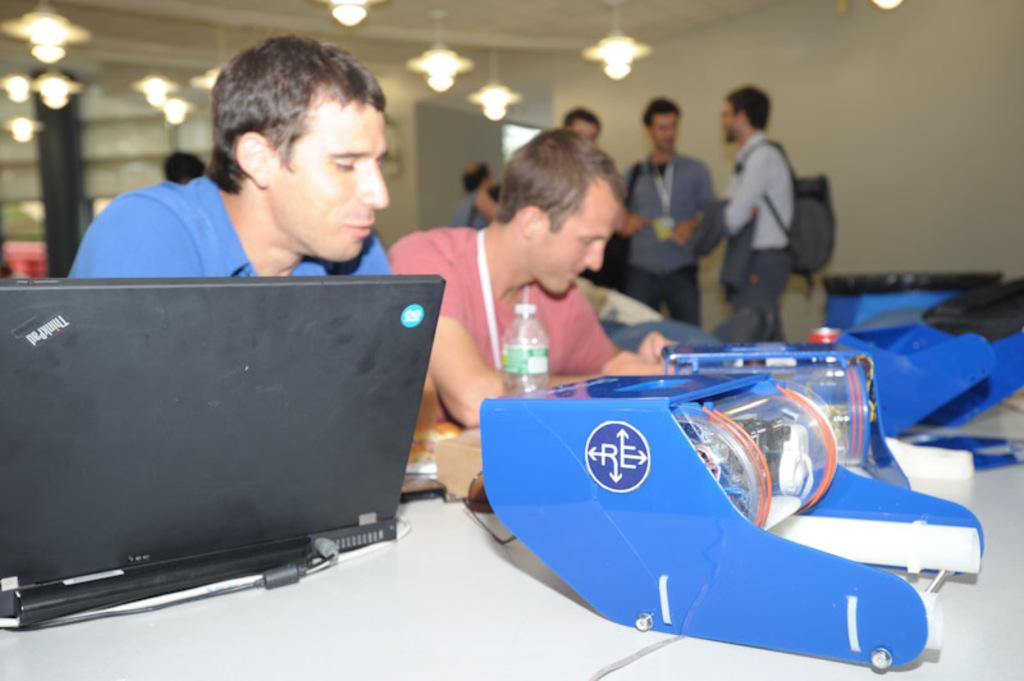What is placed on the table in the image? There is a laptop and a bottle on the table. Are there any other items on the table? Yes, there are other items on the table. What are the people in the image doing? Two people are sitting, and other people are standing at the back. What can be seen on the top of the image? There are lights on the top. What color is the nail polish on the person's hand in the image? There is no nail polish or hand visible in the image. What type of shirt is the person wearing in the image? There is no shirt visible in the image. Is there a scarf draped over the laptop in the image? There is no scarf present in the image. 